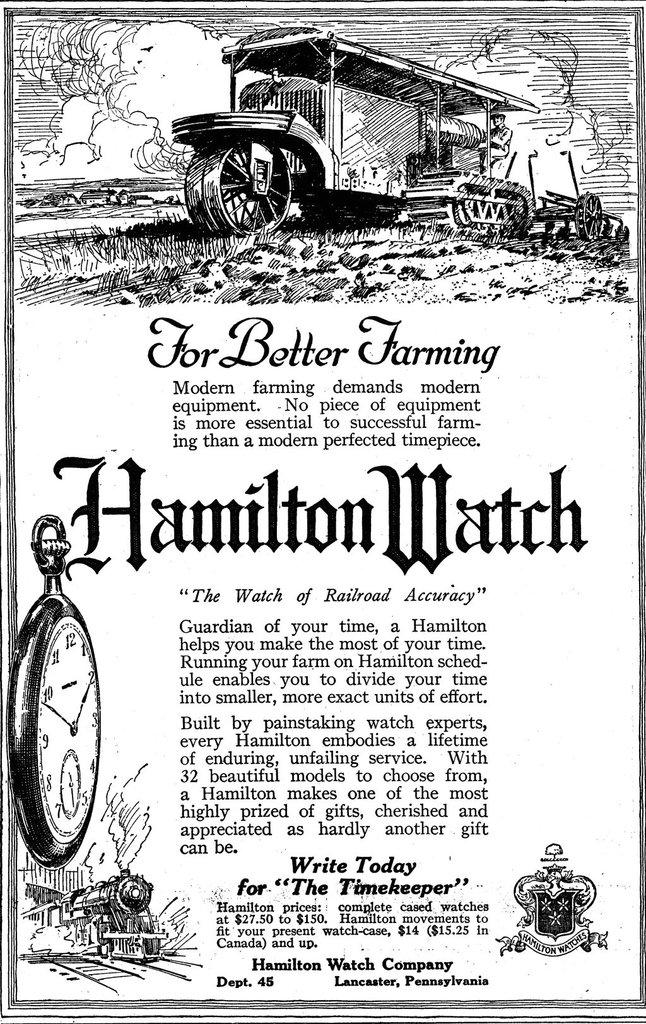What brand is being advertised here?
Your response must be concise. Hamilton watch. What state is hamilton watch located in?
Your answer should be very brief. Pennsylvania. 